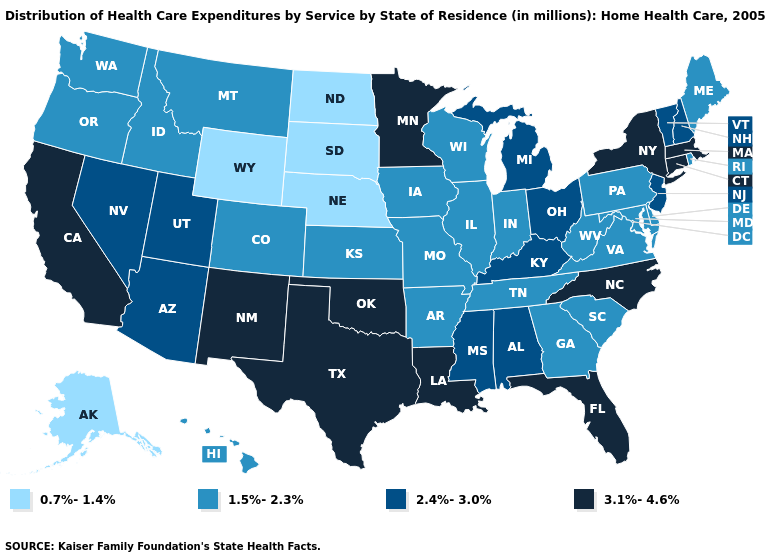Name the states that have a value in the range 2.4%-3.0%?
Write a very short answer. Alabama, Arizona, Kentucky, Michigan, Mississippi, Nevada, New Hampshire, New Jersey, Ohio, Utah, Vermont. Does the first symbol in the legend represent the smallest category?
Keep it brief. Yes. Name the states that have a value in the range 1.5%-2.3%?
Answer briefly. Arkansas, Colorado, Delaware, Georgia, Hawaii, Idaho, Illinois, Indiana, Iowa, Kansas, Maine, Maryland, Missouri, Montana, Oregon, Pennsylvania, Rhode Island, South Carolina, Tennessee, Virginia, Washington, West Virginia, Wisconsin. Does Florida have the lowest value in the USA?
Write a very short answer. No. Is the legend a continuous bar?
Short answer required. No. Is the legend a continuous bar?
Write a very short answer. No. Name the states that have a value in the range 2.4%-3.0%?
Write a very short answer. Alabama, Arizona, Kentucky, Michigan, Mississippi, Nevada, New Hampshire, New Jersey, Ohio, Utah, Vermont. Which states have the lowest value in the MidWest?
Keep it brief. Nebraska, North Dakota, South Dakota. Does Maryland have the lowest value in the South?
Answer briefly. Yes. Name the states that have a value in the range 0.7%-1.4%?
Concise answer only. Alaska, Nebraska, North Dakota, South Dakota, Wyoming. What is the lowest value in states that border Vermont?
Quick response, please. 2.4%-3.0%. What is the lowest value in states that border Arizona?
Quick response, please. 1.5%-2.3%. Which states have the highest value in the USA?
Be succinct. California, Connecticut, Florida, Louisiana, Massachusetts, Minnesota, New Mexico, New York, North Carolina, Oklahoma, Texas. 